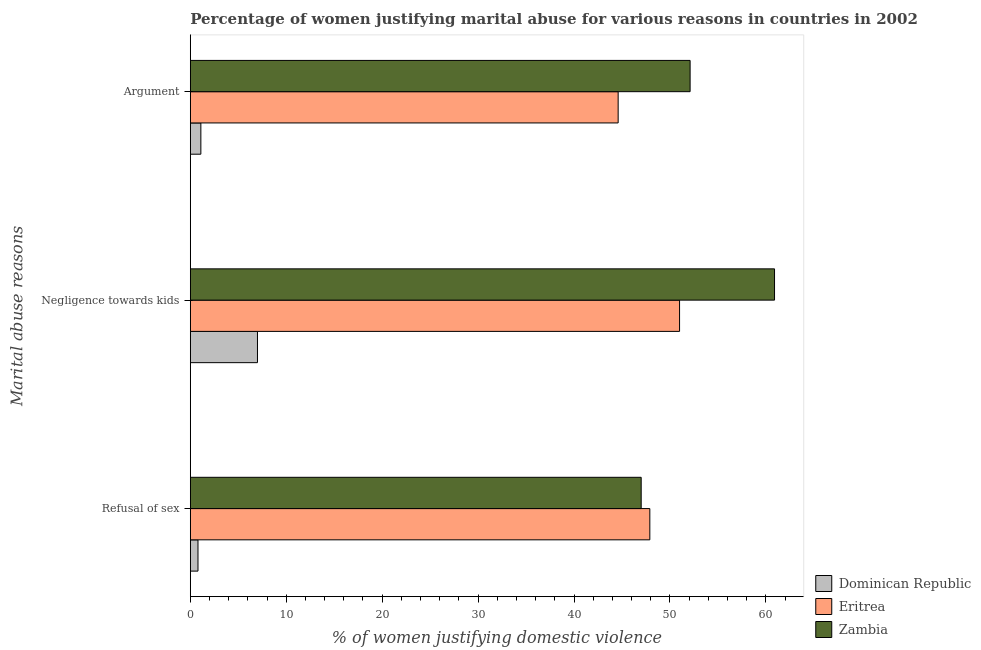How many different coloured bars are there?
Your answer should be very brief. 3. How many groups of bars are there?
Give a very brief answer. 3. Are the number of bars per tick equal to the number of legend labels?
Provide a short and direct response. Yes. What is the label of the 2nd group of bars from the top?
Your answer should be compact. Negligence towards kids. What is the percentage of women justifying domestic violence due to refusal of sex in Zambia?
Provide a short and direct response. 47. Across all countries, what is the maximum percentage of women justifying domestic violence due to arguments?
Provide a succinct answer. 52.1. In which country was the percentage of women justifying domestic violence due to negligence towards kids maximum?
Provide a short and direct response. Zambia. In which country was the percentage of women justifying domestic violence due to negligence towards kids minimum?
Ensure brevity in your answer.  Dominican Republic. What is the total percentage of women justifying domestic violence due to negligence towards kids in the graph?
Provide a succinct answer. 118.9. What is the difference between the percentage of women justifying domestic violence due to negligence towards kids in Eritrea and that in Zambia?
Provide a succinct answer. -9.9. What is the difference between the percentage of women justifying domestic violence due to refusal of sex in Eritrea and the percentage of women justifying domestic violence due to arguments in Dominican Republic?
Your answer should be compact. 46.8. What is the average percentage of women justifying domestic violence due to arguments per country?
Your answer should be compact. 32.6. What is the difference between the percentage of women justifying domestic violence due to arguments and percentage of women justifying domestic violence due to refusal of sex in Zambia?
Make the answer very short. 5.1. In how many countries, is the percentage of women justifying domestic violence due to arguments greater than 46 %?
Provide a succinct answer. 1. What is the ratio of the percentage of women justifying domestic violence due to refusal of sex in Zambia to that in Eritrea?
Your answer should be compact. 0.98. Is the difference between the percentage of women justifying domestic violence due to arguments in Dominican Republic and Zambia greater than the difference between the percentage of women justifying domestic violence due to negligence towards kids in Dominican Republic and Zambia?
Give a very brief answer. Yes. What is the difference between the highest and the second highest percentage of women justifying domestic violence due to negligence towards kids?
Keep it short and to the point. 9.9. What is the difference between the highest and the lowest percentage of women justifying domestic violence due to negligence towards kids?
Offer a very short reply. 53.9. Is the sum of the percentage of women justifying domestic violence due to arguments in Dominican Republic and Eritrea greater than the maximum percentage of women justifying domestic violence due to negligence towards kids across all countries?
Your response must be concise. No. What does the 3rd bar from the top in Argument represents?
Offer a terse response. Dominican Republic. What does the 3rd bar from the bottom in Argument represents?
Keep it short and to the point. Zambia. Is it the case that in every country, the sum of the percentage of women justifying domestic violence due to refusal of sex and percentage of women justifying domestic violence due to negligence towards kids is greater than the percentage of women justifying domestic violence due to arguments?
Offer a terse response. Yes. Are all the bars in the graph horizontal?
Give a very brief answer. Yes. How many countries are there in the graph?
Your answer should be very brief. 3. Does the graph contain any zero values?
Give a very brief answer. No. Does the graph contain grids?
Provide a short and direct response. No. Where does the legend appear in the graph?
Provide a short and direct response. Bottom right. How many legend labels are there?
Offer a very short reply. 3. How are the legend labels stacked?
Provide a short and direct response. Vertical. What is the title of the graph?
Offer a very short reply. Percentage of women justifying marital abuse for various reasons in countries in 2002. Does "Isle of Man" appear as one of the legend labels in the graph?
Provide a short and direct response. No. What is the label or title of the X-axis?
Offer a very short reply. % of women justifying domestic violence. What is the label or title of the Y-axis?
Provide a short and direct response. Marital abuse reasons. What is the % of women justifying domestic violence in Dominican Republic in Refusal of sex?
Make the answer very short. 0.8. What is the % of women justifying domestic violence of Eritrea in Refusal of sex?
Ensure brevity in your answer.  47.9. What is the % of women justifying domestic violence of Zambia in Refusal of sex?
Offer a very short reply. 47. What is the % of women justifying domestic violence in Dominican Republic in Negligence towards kids?
Offer a very short reply. 7. What is the % of women justifying domestic violence of Zambia in Negligence towards kids?
Your answer should be very brief. 60.9. What is the % of women justifying domestic violence of Dominican Republic in Argument?
Offer a terse response. 1.1. What is the % of women justifying domestic violence in Eritrea in Argument?
Make the answer very short. 44.6. What is the % of women justifying domestic violence in Zambia in Argument?
Your answer should be compact. 52.1. Across all Marital abuse reasons, what is the maximum % of women justifying domestic violence in Dominican Republic?
Make the answer very short. 7. Across all Marital abuse reasons, what is the maximum % of women justifying domestic violence in Zambia?
Give a very brief answer. 60.9. Across all Marital abuse reasons, what is the minimum % of women justifying domestic violence in Dominican Republic?
Provide a short and direct response. 0.8. Across all Marital abuse reasons, what is the minimum % of women justifying domestic violence of Eritrea?
Your answer should be compact. 44.6. What is the total % of women justifying domestic violence of Eritrea in the graph?
Your answer should be compact. 143.5. What is the total % of women justifying domestic violence of Zambia in the graph?
Your answer should be compact. 160. What is the difference between the % of women justifying domestic violence of Dominican Republic in Refusal of sex and that in Negligence towards kids?
Give a very brief answer. -6.2. What is the difference between the % of women justifying domestic violence of Eritrea in Refusal of sex and that in Negligence towards kids?
Keep it short and to the point. -3.1. What is the difference between the % of women justifying domestic violence in Dominican Republic in Refusal of sex and that in Argument?
Give a very brief answer. -0.3. What is the difference between the % of women justifying domestic violence in Eritrea in Refusal of sex and that in Argument?
Make the answer very short. 3.3. What is the difference between the % of women justifying domestic violence of Zambia in Refusal of sex and that in Argument?
Keep it short and to the point. -5.1. What is the difference between the % of women justifying domestic violence of Dominican Republic in Negligence towards kids and that in Argument?
Your response must be concise. 5.9. What is the difference between the % of women justifying domestic violence in Eritrea in Negligence towards kids and that in Argument?
Ensure brevity in your answer.  6.4. What is the difference between the % of women justifying domestic violence in Dominican Republic in Refusal of sex and the % of women justifying domestic violence in Eritrea in Negligence towards kids?
Provide a short and direct response. -50.2. What is the difference between the % of women justifying domestic violence of Dominican Republic in Refusal of sex and the % of women justifying domestic violence of Zambia in Negligence towards kids?
Your answer should be compact. -60.1. What is the difference between the % of women justifying domestic violence in Eritrea in Refusal of sex and the % of women justifying domestic violence in Zambia in Negligence towards kids?
Your response must be concise. -13. What is the difference between the % of women justifying domestic violence in Dominican Republic in Refusal of sex and the % of women justifying domestic violence in Eritrea in Argument?
Provide a succinct answer. -43.8. What is the difference between the % of women justifying domestic violence in Dominican Republic in Refusal of sex and the % of women justifying domestic violence in Zambia in Argument?
Provide a short and direct response. -51.3. What is the difference between the % of women justifying domestic violence in Eritrea in Refusal of sex and the % of women justifying domestic violence in Zambia in Argument?
Offer a very short reply. -4.2. What is the difference between the % of women justifying domestic violence of Dominican Republic in Negligence towards kids and the % of women justifying domestic violence of Eritrea in Argument?
Provide a short and direct response. -37.6. What is the difference between the % of women justifying domestic violence of Dominican Republic in Negligence towards kids and the % of women justifying domestic violence of Zambia in Argument?
Offer a very short reply. -45.1. What is the difference between the % of women justifying domestic violence of Eritrea in Negligence towards kids and the % of women justifying domestic violence of Zambia in Argument?
Your answer should be compact. -1.1. What is the average % of women justifying domestic violence in Dominican Republic per Marital abuse reasons?
Your answer should be compact. 2.97. What is the average % of women justifying domestic violence in Eritrea per Marital abuse reasons?
Offer a very short reply. 47.83. What is the average % of women justifying domestic violence of Zambia per Marital abuse reasons?
Your response must be concise. 53.33. What is the difference between the % of women justifying domestic violence in Dominican Republic and % of women justifying domestic violence in Eritrea in Refusal of sex?
Give a very brief answer. -47.1. What is the difference between the % of women justifying domestic violence in Dominican Republic and % of women justifying domestic violence in Zambia in Refusal of sex?
Your answer should be very brief. -46.2. What is the difference between the % of women justifying domestic violence in Eritrea and % of women justifying domestic violence in Zambia in Refusal of sex?
Provide a short and direct response. 0.9. What is the difference between the % of women justifying domestic violence of Dominican Republic and % of women justifying domestic violence of Eritrea in Negligence towards kids?
Offer a terse response. -44. What is the difference between the % of women justifying domestic violence of Dominican Republic and % of women justifying domestic violence of Zambia in Negligence towards kids?
Ensure brevity in your answer.  -53.9. What is the difference between the % of women justifying domestic violence of Eritrea and % of women justifying domestic violence of Zambia in Negligence towards kids?
Provide a succinct answer. -9.9. What is the difference between the % of women justifying domestic violence of Dominican Republic and % of women justifying domestic violence of Eritrea in Argument?
Give a very brief answer. -43.5. What is the difference between the % of women justifying domestic violence in Dominican Republic and % of women justifying domestic violence in Zambia in Argument?
Make the answer very short. -51. What is the difference between the % of women justifying domestic violence in Eritrea and % of women justifying domestic violence in Zambia in Argument?
Make the answer very short. -7.5. What is the ratio of the % of women justifying domestic violence in Dominican Republic in Refusal of sex to that in Negligence towards kids?
Give a very brief answer. 0.11. What is the ratio of the % of women justifying domestic violence of Eritrea in Refusal of sex to that in Negligence towards kids?
Your response must be concise. 0.94. What is the ratio of the % of women justifying domestic violence of Zambia in Refusal of sex to that in Negligence towards kids?
Give a very brief answer. 0.77. What is the ratio of the % of women justifying domestic violence of Dominican Republic in Refusal of sex to that in Argument?
Provide a short and direct response. 0.73. What is the ratio of the % of women justifying domestic violence in Eritrea in Refusal of sex to that in Argument?
Your response must be concise. 1.07. What is the ratio of the % of women justifying domestic violence in Zambia in Refusal of sex to that in Argument?
Make the answer very short. 0.9. What is the ratio of the % of women justifying domestic violence in Dominican Republic in Negligence towards kids to that in Argument?
Your answer should be compact. 6.36. What is the ratio of the % of women justifying domestic violence in Eritrea in Negligence towards kids to that in Argument?
Your answer should be very brief. 1.14. What is the ratio of the % of women justifying domestic violence in Zambia in Negligence towards kids to that in Argument?
Offer a terse response. 1.17. What is the difference between the highest and the second highest % of women justifying domestic violence of Dominican Republic?
Provide a succinct answer. 5.9. What is the difference between the highest and the second highest % of women justifying domestic violence in Eritrea?
Give a very brief answer. 3.1. What is the difference between the highest and the second highest % of women justifying domestic violence in Zambia?
Keep it short and to the point. 8.8. What is the difference between the highest and the lowest % of women justifying domestic violence of Dominican Republic?
Offer a very short reply. 6.2. What is the difference between the highest and the lowest % of women justifying domestic violence of Eritrea?
Offer a very short reply. 6.4. What is the difference between the highest and the lowest % of women justifying domestic violence of Zambia?
Your answer should be compact. 13.9. 